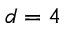<formula> <loc_0><loc_0><loc_500><loc_500>d = 4</formula> 